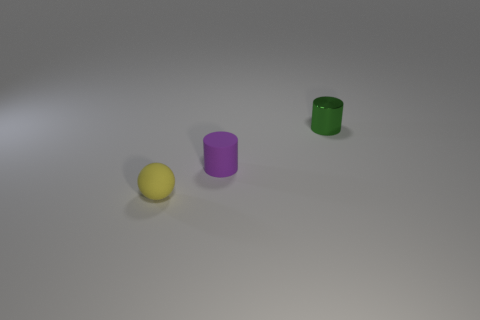Is there anything notable about the arrangement of the objects? The objects are spaced out on a flat surface with no overlap, allowing each item to be distinct and easily identifiable. The arrangement appears intentional but does not seem to follow any recognizable pattern or order. 